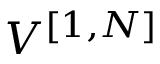<formula> <loc_0><loc_0><loc_500><loc_500>V ^ { [ { 1 } , { N } ] }</formula> 